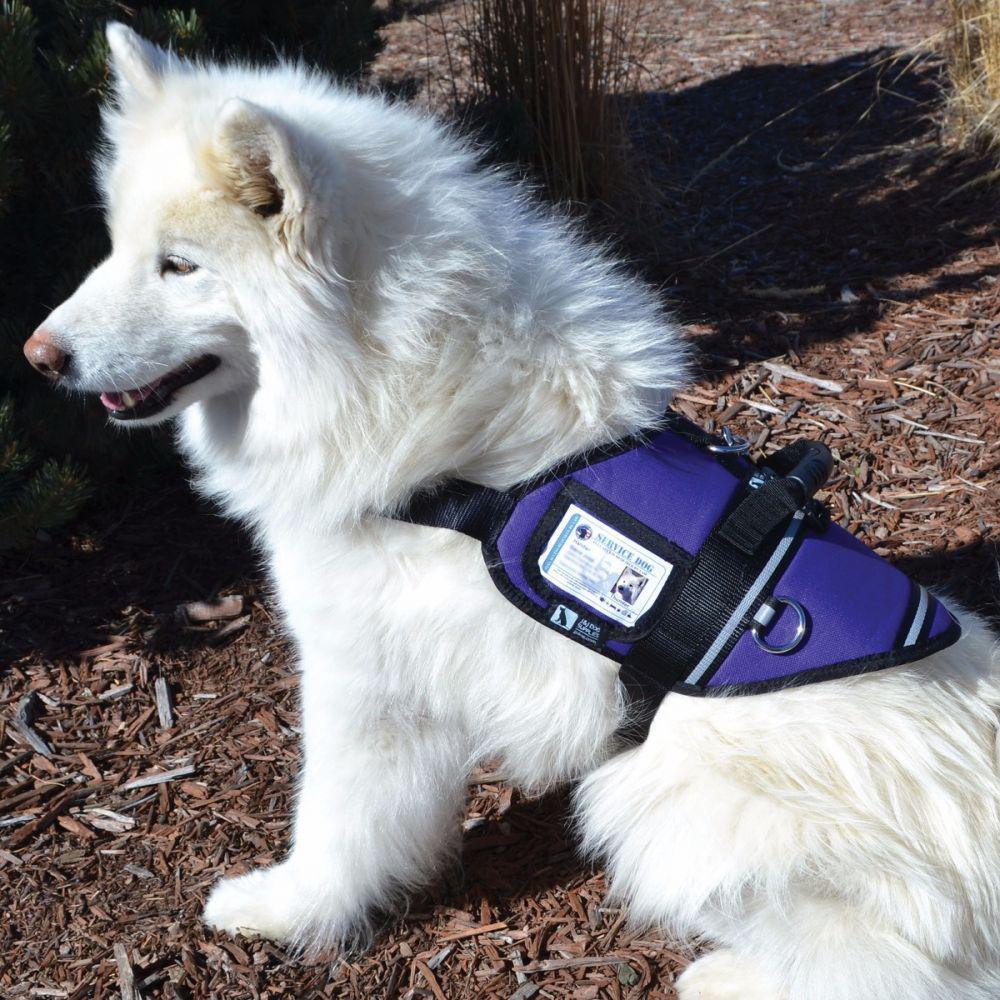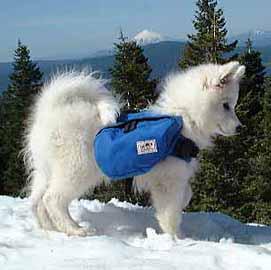The first image is the image on the left, the second image is the image on the right. Assess this claim about the two images: "There are two samoyed dogs outside in the center of the images.". Correct or not? Answer yes or no. Yes. The first image is the image on the left, the second image is the image on the right. Examine the images to the left and right. Is the description "There is a white dog facing the right with trees in the background." accurate? Answer yes or no. Yes. 